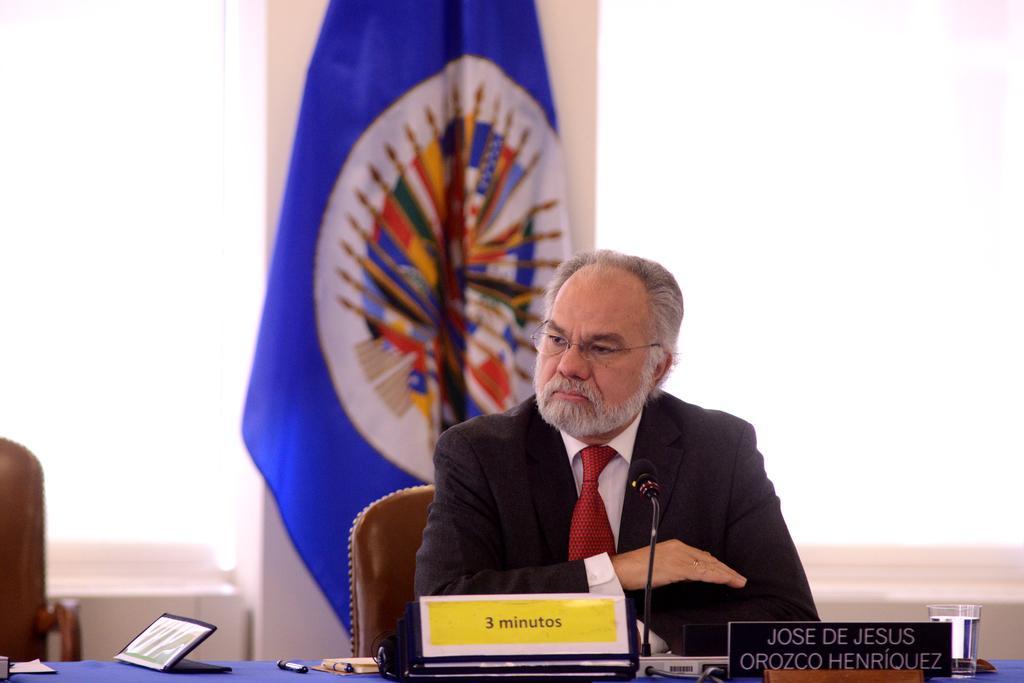In one or two sentences, can you explain what this image depicts? In this picture I can observe a man sitting in the chair in front of a table on which I can observe a name board, water glass and a mic. The man is wearing coat, tie and spectacles. In the background I can observe a flag which is in blue color. 